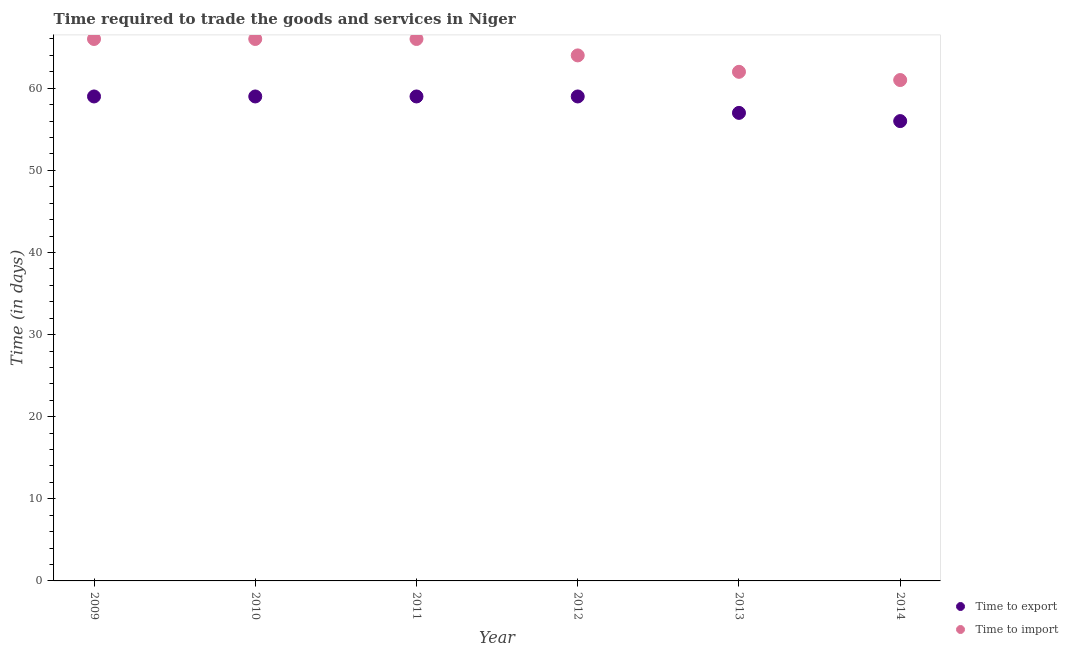How many different coloured dotlines are there?
Offer a very short reply. 2. Is the number of dotlines equal to the number of legend labels?
Provide a short and direct response. Yes. What is the time to export in 2014?
Keep it short and to the point. 56. Across all years, what is the maximum time to import?
Your response must be concise. 66. Across all years, what is the minimum time to import?
Your answer should be very brief. 61. What is the total time to export in the graph?
Ensure brevity in your answer.  349. What is the difference between the time to import in 2010 and that in 2014?
Your answer should be very brief. 5. What is the difference between the time to import in 2010 and the time to export in 2012?
Offer a terse response. 7. What is the average time to import per year?
Offer a very short reply. 64.17. In the year 2013, what is the difference between the time to import and time to export?
Offer a terse response. 5. What is the ratio of the time to export in 2009 to that in 2014?
Offer a very short reply. 1.05. Is the time to export in 2012 less than that in 2014?
Provide a short and direct response. No. Is the difference between the time to export in 2013 and 2014 greater than the difference between the time to import in 2013 and 2014?
Give a very brief answer. No. What is the difference between the highest and the second highest time to export?
Offer a terse response. 0. What is the difference between the highest and the lowest time to import?
Make the answer very short. 5. Does the time to import monotonically increase over the years?
Provide a short and direct response. No. Is the time to import strictly greater than the time to export over the years?
Your answer should be very brief. Yes. Is the time to export strictly less than the time to import over the years?
Provide a succinct answer. Yes. How many dotlines are there?
Your response must be concise. 2. How many years are there in the graph?
Give a very brief answer. 6. What is the difference between two consecutive major ticks on the Y-axis?
Offer a very short reply. 10. Does the graph contain any zero values?
Offer a terse response. No. Does the graph contain grids?
Your answer should be compact. No. Where does the legend appear in the graph?
Ensure brevity in your answer.  Bottom right. How many legend labels are there?
Provide a succinct answer. 2. How are the legend labels stacked?
Offer a terse response. Vertical. What is the title of the graph?
Provide a succinct answer. Time required to trade the goods and services in Niger. Does "Taxes" appear as one of the legend labels in the graph?
Provide a short and direct response. No. What is the label or title of the X-axis?
Your answer should be compact. Year. What is the label or title of the Y-axis?
Make the answer very short. Time (in days). What is the Time (in days) in Time to import in 2010?
Offer a very short reply. 66. What is the Time (in days) in Time to export in 2011?
Your answer should be very brief. 59. What is the Time (in days) of Time to import in 2014?
Ensure brevity in your answer.  61. Across all years, what is the maximum Time (in days) in Time to export?
Provide a short and direct response. 59. Across all years, what is the maximum Time (in days) in Time to import?
Ensure brevity in your answer.  66. What is the total Time (in days) in Time to export in the graph?
Your response must be concise. 349. What is the total Time (in days) in Time to import in the graph?
Your answer should be very brief. 385. What is the difference between the Time (in days) in Time to import in 2009 and that in 2010?
Give a very brief answer. 0. What is the difference between the Time (in days) of Time to export in 2009 and that in 2011?
Your answer should be compact. 0. What is the difference between the Time (in days) in Time to export in 2009 and that in 2012?
Provide a short and direct response. 0. What is the difference between the Time (in days) in Time to import in 2009 and that in 2012?
Offer a very short reply. 2. What is the difference between the Time (in days) in Time to export in 2009 and that in 2013?
Provide a short and direct response. 2. What is the difference between the Time (in days) of Time to import in 2009 and that in 2013?
Ensure brevity in your answer.  4. What is the difference between the Time (in days) of Time to export in 2009 and that in 2014?
Your answer should be very brief. 3. What is the difference between the Time (in days) in Time to import in 2009 and that in 2014?
Ensure brevity in your answer.  5. What is the difference between the Time (in days) of Time to export in 2010 and that in 2012?
Offer a very short reply. 0. What is the difference between the Time (in days) in Time to import in 2010 and that in 2012?
Keep it short and to the point. 2. What is the difference between the Time (in days) of Time to export in 2011 and that in 2012?
Offer a terse response. 0. What is the difference between the Time (in days) of Time to export in 2011 and that in 2013?
Offer a terse response. 2. What is the difference between the Time (in days) of Time to import in 2011 and that in 2013?
Your response must be concise. 4. What is the difference between the Time (in days) of Time to import in 2012 and that in 2013?
Keep it short and to the point. 2. What is the difference between the Time (in days) in Time to import in 2012 and that in 2014?
Offer a terse response. 3. What is the difference between the Time (in days) in Time to import in 2013 and that in 2014?
Provide a succinct answer. 1. What is the difference between the Time (in days) of Time to export in 2009 and the Time (in days) of Time to import in 2010?
Keep it short and to the point. -7. What is the difference between the Time (in days) in Time to export in 2009 and the Time (in days) in Time to import in 2011?
Your response must be concise. -7. What is the difference between the Time (in days) of Time to export in 2009 and the Time (in days) of Time to import in 2012?
Offer a terse response. -5. What is the difference between the Time (in days) of Time to export in 2009 and the Time (in days) of Time to import in 2014?
Offer a very short reply. -2. What is the difference between the Time (in days) in Time to export in 2010 and the Time (in days) in Time to import in 2011?
Your answer should be very brief. -7. What is the difference between the Time (in days) of Time to export in 2010 and the Time (in days) of Time to import in 2012?
Make the answer very short. -5. What is the difference between the Time (in days) of Time to export in 2010 and the Time (in days) of Time to import in 2013?
Ensure brevity in your answer.  -3. What is the difference between the Time (in days) of Time to export in 2010 and the Time (in days) of Time to import in 2014?
Keep it short and to the point. -2. What is the difference between the Time (in days) of Time to export in 2012 and the Time (in days) of Time to import in 2013?
Provide a short and direct response. -3. What is the difference between the Time (in days) in Time to export in 2012 and the Time (in days) in Time to import in 2014?
Your response must be concise. -2. What is the average Time (in days) in Time to export per year?
Your answer should be compact. 58.17. What is the average Time (in days) in Time to import per year?
Provide a succinct answer. 64.17. In the year 2009, what is the difference between the Time (in days) of Time to export and Time (in days) of Time to import?
Offer a terse response. -7. In the year 2010, what is the difference between the Time (in days) in Time to export and Time (in days) in Time to import?
Offer a terse response. -7. In the year 2011, what is the difference between the Time (in days) in Time to export and Time (in days) in Time to import?
Give a very brief answer. -7. In the year 2014, what is the difference between the Time (in days) of Time to export and Time (in days) of Time to import?
Offer a terse response. -5. What is the ratio of the Time (in days) of Time to import in 2009 to that in 2011?
Make the answer very short. 1. What is the ratio of the Time (in days) of Time to import in 2009 to that in 2012?
Make the answer very short. 1.03. What is the ratio of the Time (in days) in Time to export in 2009 to that in 2013?
Keep it short and to the point. 1.04. What is the ratio of the Time (in days) in Time to import in 2009 to that in 2013?
Your answer should be compact. 1.06. What is the ratio of the Time (in days) in Time to export in 2009 to that in 2014?
Your answer should be compact. 1.05. What is the ratio of the Time (in days) in Time to import in 2009 to that in 2014?
Offer a very short reply. 1.08. What is the ratio of the Time (in days) of Time to import in 2010 to that in 2011?
Your answer should be very brief. 1. What is the ratio of the Time (in days) in Time to import in 2010 to that in 2012?
Offer a terse response. 1.03. What is the ratio of the Time (in days) in Time to export in 2010 to that in 2013?
Provide a short and direct response. 1.04. What is the ratio of the Time (in days) of Time to import in 2010 to that in 2013?
Provide a short and direct response. 1.06. What is the ratio of the Time (in days) of Time to export in 2010 to that in 2014?
Keep it short and to the point. 1.05. What is the ratio of the Time (in days) in Time to import in 2010 to that in 2014?
Your response must be concise. 1.08. What is the ratio of the Time (in days) of Time to import in 2011 to that in 2012?
Give a very brief answer. 1.03. What is the ratio of the Time (in days) of Time to export in 2011 to that in 2013?
Your response must be concise. 1.04. What is the ratio of the Time (in days) of Time to import in 2011 to that in 2013?
Ensure brevity in your answer.  1.06. What is the ratio of the Time (in days) in Time to export in 2011 to that in 2014?
Your answer should be very brief. 1.05. What is the ratio of the Time (in days) of Time to import in 2011 to that in 2014?
Give a very brief answer. 1.08. What is the ratio of the Time (in days) in Time to export in 2012 to that in 2013?
Give a very brief answer. 1.04. What is the ratio of the Time (in days) in Time to import in 2012 to that in 2013?
Offer a very short reply. 1.03. What is the ratio of the Time (in days) of Time to export in 2012 to that in 2014?
Make the answer very short. 1.05. What is the ratio of the Time (in days) of Time to import in 2012 to that in 2014?
Make the answer very short. 1.05. What is the ratio of the Time (in days) in Time to export in 2013 to that in 2014?
Offer a very short reply. 1.02. What is the ratio of the Time (in days) in Time to import in 2013 to that in 2014?
Your answer should be compact. 1.02. What is the difference between the highest and the second highest Time (in days) of Time to import?
Your answer should be compact. 0. What is the difference between the highest and the lowest Time (in days) in Time to export?
Make the answer very short. 3. 